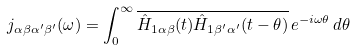<formula> <loc_0><loc_0><loc_500><loc_500>j _ { \alpha \beta \alpha ^ { \prime } \beta ^ { \prime } } ( \omega ) = \int _ { 0 } ^ { \infty } \overline { \hat { H } _ { 1 \alpha \beta } ( t ) \hat { H } _ { 1 \beta ^ { \prime } \alpha ^ { \prime } } ( t - \theta ) } \, e ^ { - i \omega \theta } \, d \theta</formula> 